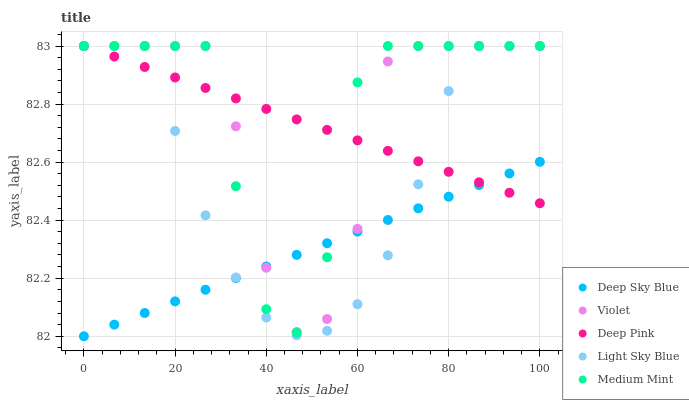Does Deep Sky Blue have the minimum area under the curve?
Answer yes or no. Yes. Does Medium Mint have the maximum area under the curve?
Answer yes or no. Yes. Does Light Sky Blue have the minimum area under the curve?
Answer yes or no. No. Does Light Sky Blue have the maximum area under the curve?
Answer yes or no. No. Is Deep Pink the smoothest?
Answer yes or no. Yes. Is Medium Mint the roughest?
Answer yes or no. Yes. Is Light Sky Blue the smoothest?
Answer yes or no. No. Is Light Sky Blue the roughest?
Answer yes or no. No. Does Deep Sky Blue have the lowest value?
Answer yes or no. Yes. Does Light Sky Blue have the lowest value?
Answer yes or no. No. Does Violet have the highest value?
Answer yes or no. Yes. Does Deep Sky Blue have the highest value?
Answer yes or no. No. Does Medium Mint intersect Violet?
Answer yes or no. Yes. Is Medium Mint less than Violet?
Answer yes or no. No. Is Medium Mint greater than Violet?
Answer yes or no. No. 